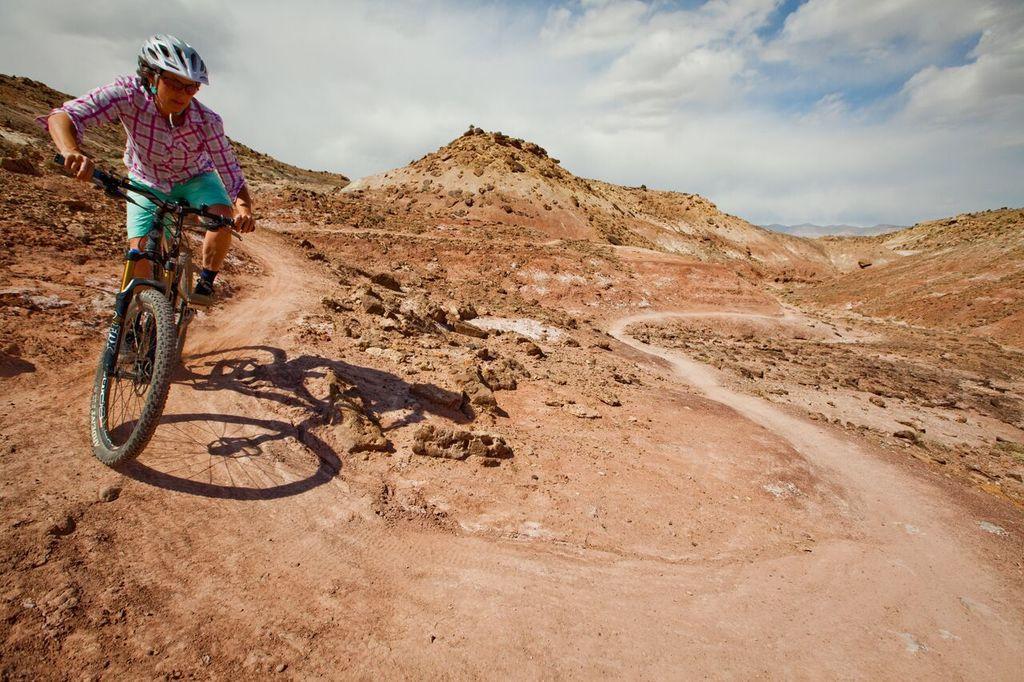Please provide a concise description of this image. In this image, we can see a person riding a bicycle. We can see the ground and some hills. We can see some mud rocks. We can see the shadow of a person and the bicycle on the ground. We can also see the sky with clouds. 